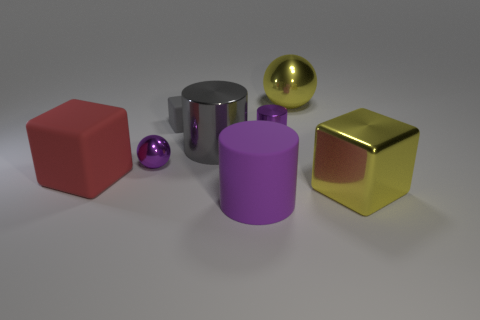Subtract all large yellow cubes. How many cubes are left? 2 Subtract all purple cubes. How many purple cylinders are left? 2 Add 1 yellow blocks. How many objects exist? 9 Subtract all gray blocks. How many blocks are left? 2 Subtract all spheres. How many objects are left? 6 Add 6 small purple shiny cylinders. How many small purple shiny cylinders are left? 7 Add 4 purple rubber balls. How many purple rubber balls exist? 4 Subtract 1 purple balls. How many objects are left? 7 Subtract all purple blocks. Subtract all gray cylinders. How many blocks are left? 3 Subtract all green matte cylinders. Subtract all small purple cylinders. How many objects are left? 7 